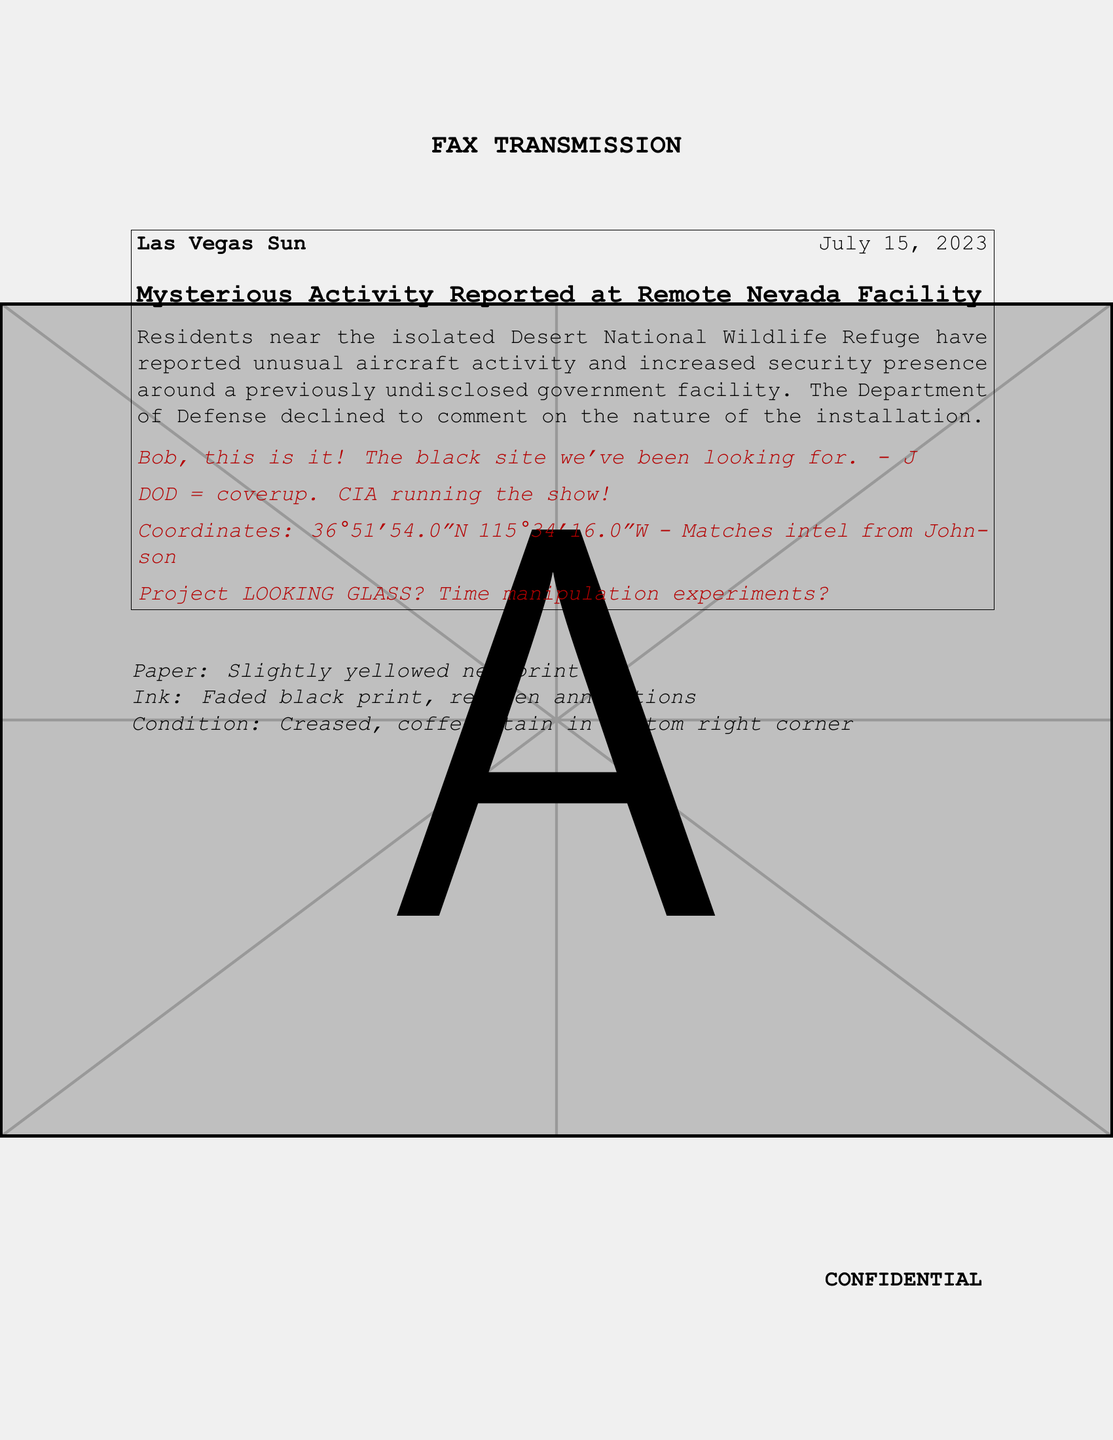What is the date of the newspaper article? The date is mentioned at the beginning of the article, which is July 15, 2023.
Answer: July 15, 2023 What is the name of the newspaper? The name of the newspaper is indicated prominently at the top of the clipping.
Answer: Las Vegas Sun What unusual activity is reported? The article indicates "unusual aircraft activity and increased security presence" as the unusual activity.
Answer: Unusual aircraft activity and increased security presence What does DOD stand for in the context of the annotations? The acronym DOD is mentioned in the annotations referring to the Department of Defense.
Answer: Department of Defense What is written in the first annotation? The first annotation explicitly states a claim about the "black site".
Answer: Bob, this is it! The black site we've been looking for. - J What does the annotation suggest about Project LOOKING GLASS? The annotation raises a question about potential experiments related to time manipulation.
Answer: Time manipulation experiments? What are the coordinates provided in the document? The coordinates mentioned in the annotation are given as a specific format in degrees.
Answer: 36°51'54.0"N 115°34'16.0"W What does the document indicate about the condition of the paper? The condition is described with specific details including discoloration and stains.
Answer: Slightly yellowed newsprint What is the confidentiality status of the fax? The fax includes a statement indicating that it is confidential.
Answer: CONFIDENTIAL 